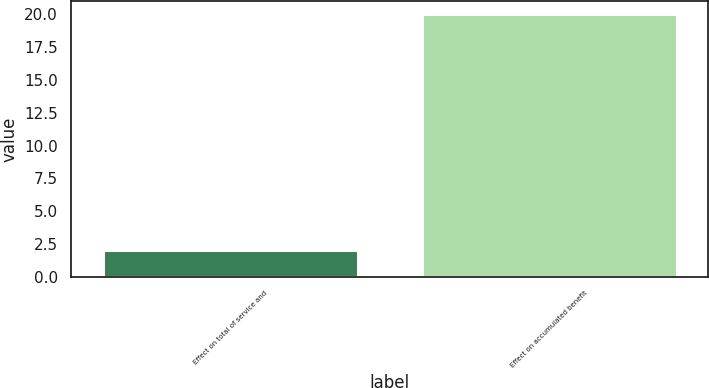Convert chart to OTSL. <chart><loc_0><loc_0><loc_500><loc_500><bar_chart><fcel>Effect on total of service and<fcel>Effect on accumulated benefit<nl><fcel>2<fcel>20<nl></chart> 